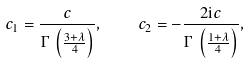<formula> <loc_0><loc_0><loc_500><loc_500>c _ { 1 } = \frac { c } { \Gamma \, \left ( \frac { 3 + \lambda } 4 \right ) } , \quad c _ { 2 } = - \frac { 2 \mathrm i c } { \Gamma \, \left ( \frac { 1 + \lambda } 4 \right ) } ,</formula> 